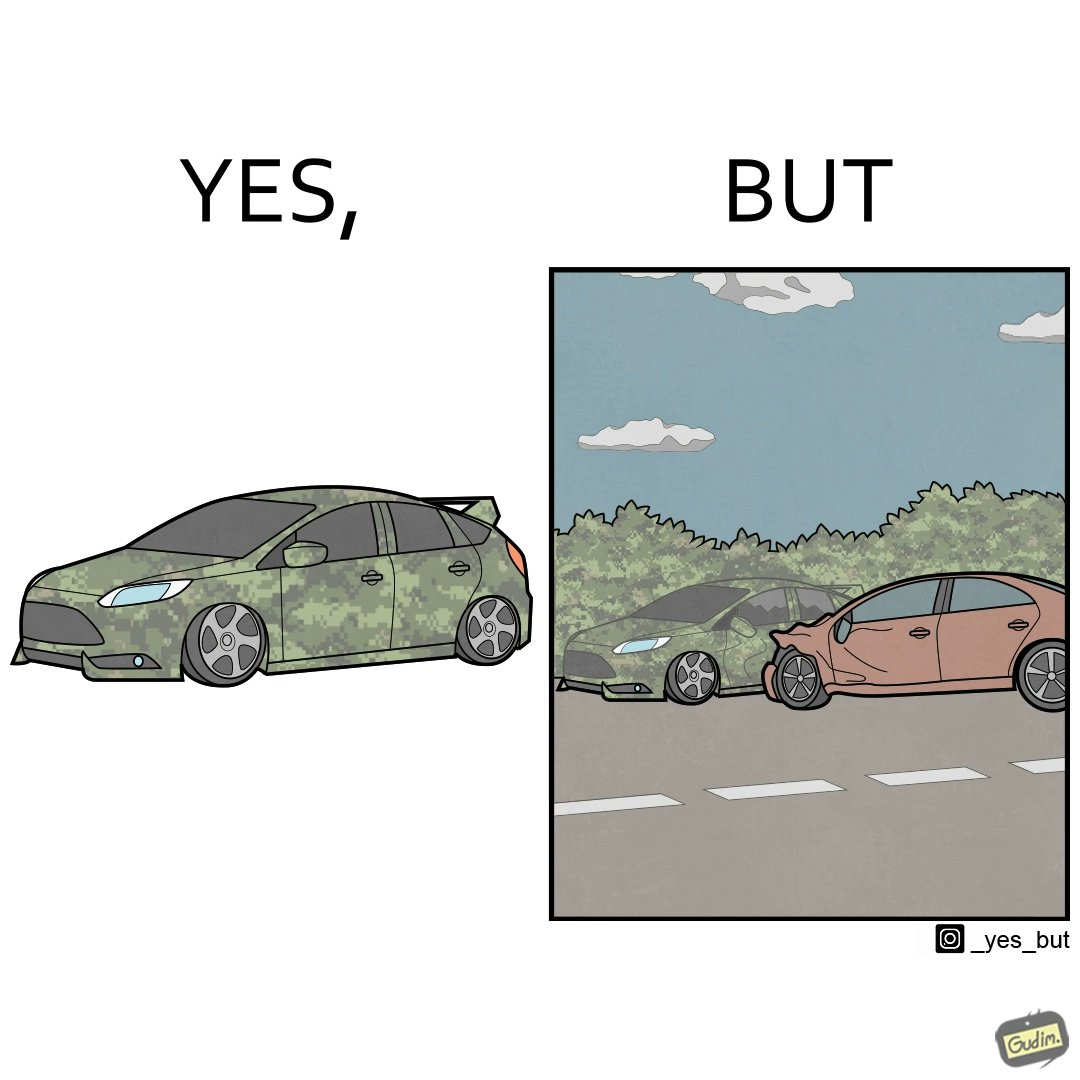What do you see in each half of this image? In the left part of the image: a car painted in a camouflage color In the right part of the image: a red color car crashing into a camouflage color car due to the background of green plants 